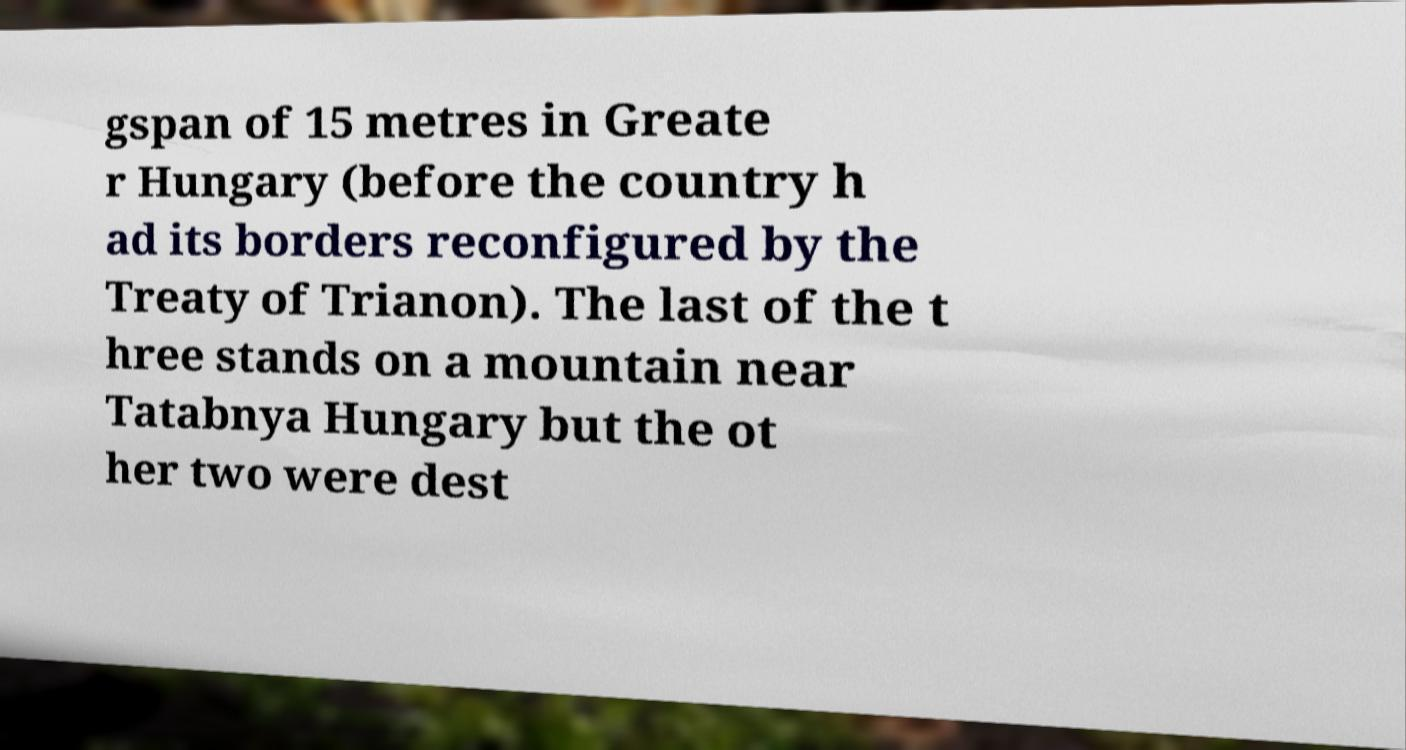Could you assist in decoding the text presented in this image and type it out clearly? gspan of 15 metres in Greate r Hungary (before the country h ad its borders reconfigured by the Treaty of Trianon). The last of the t hree stands on a mountain near Tatabnya Hungary but the ot her two were dest 